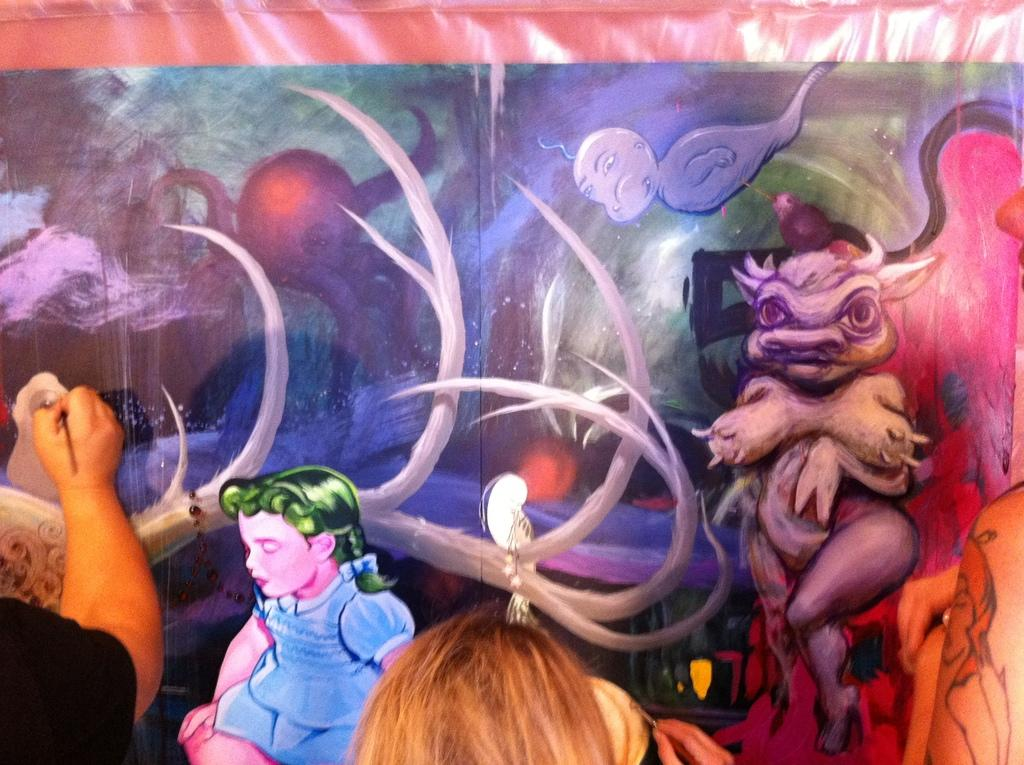How many people are present in the image? There are two persons in the image. What are the two persons doing in the image? The two persons are painting. What type of berry is being used as a paintbrush by one of the persons in the image? There is no berry present in the image, and the persons are not using any unconventional items as paintbrushes. 